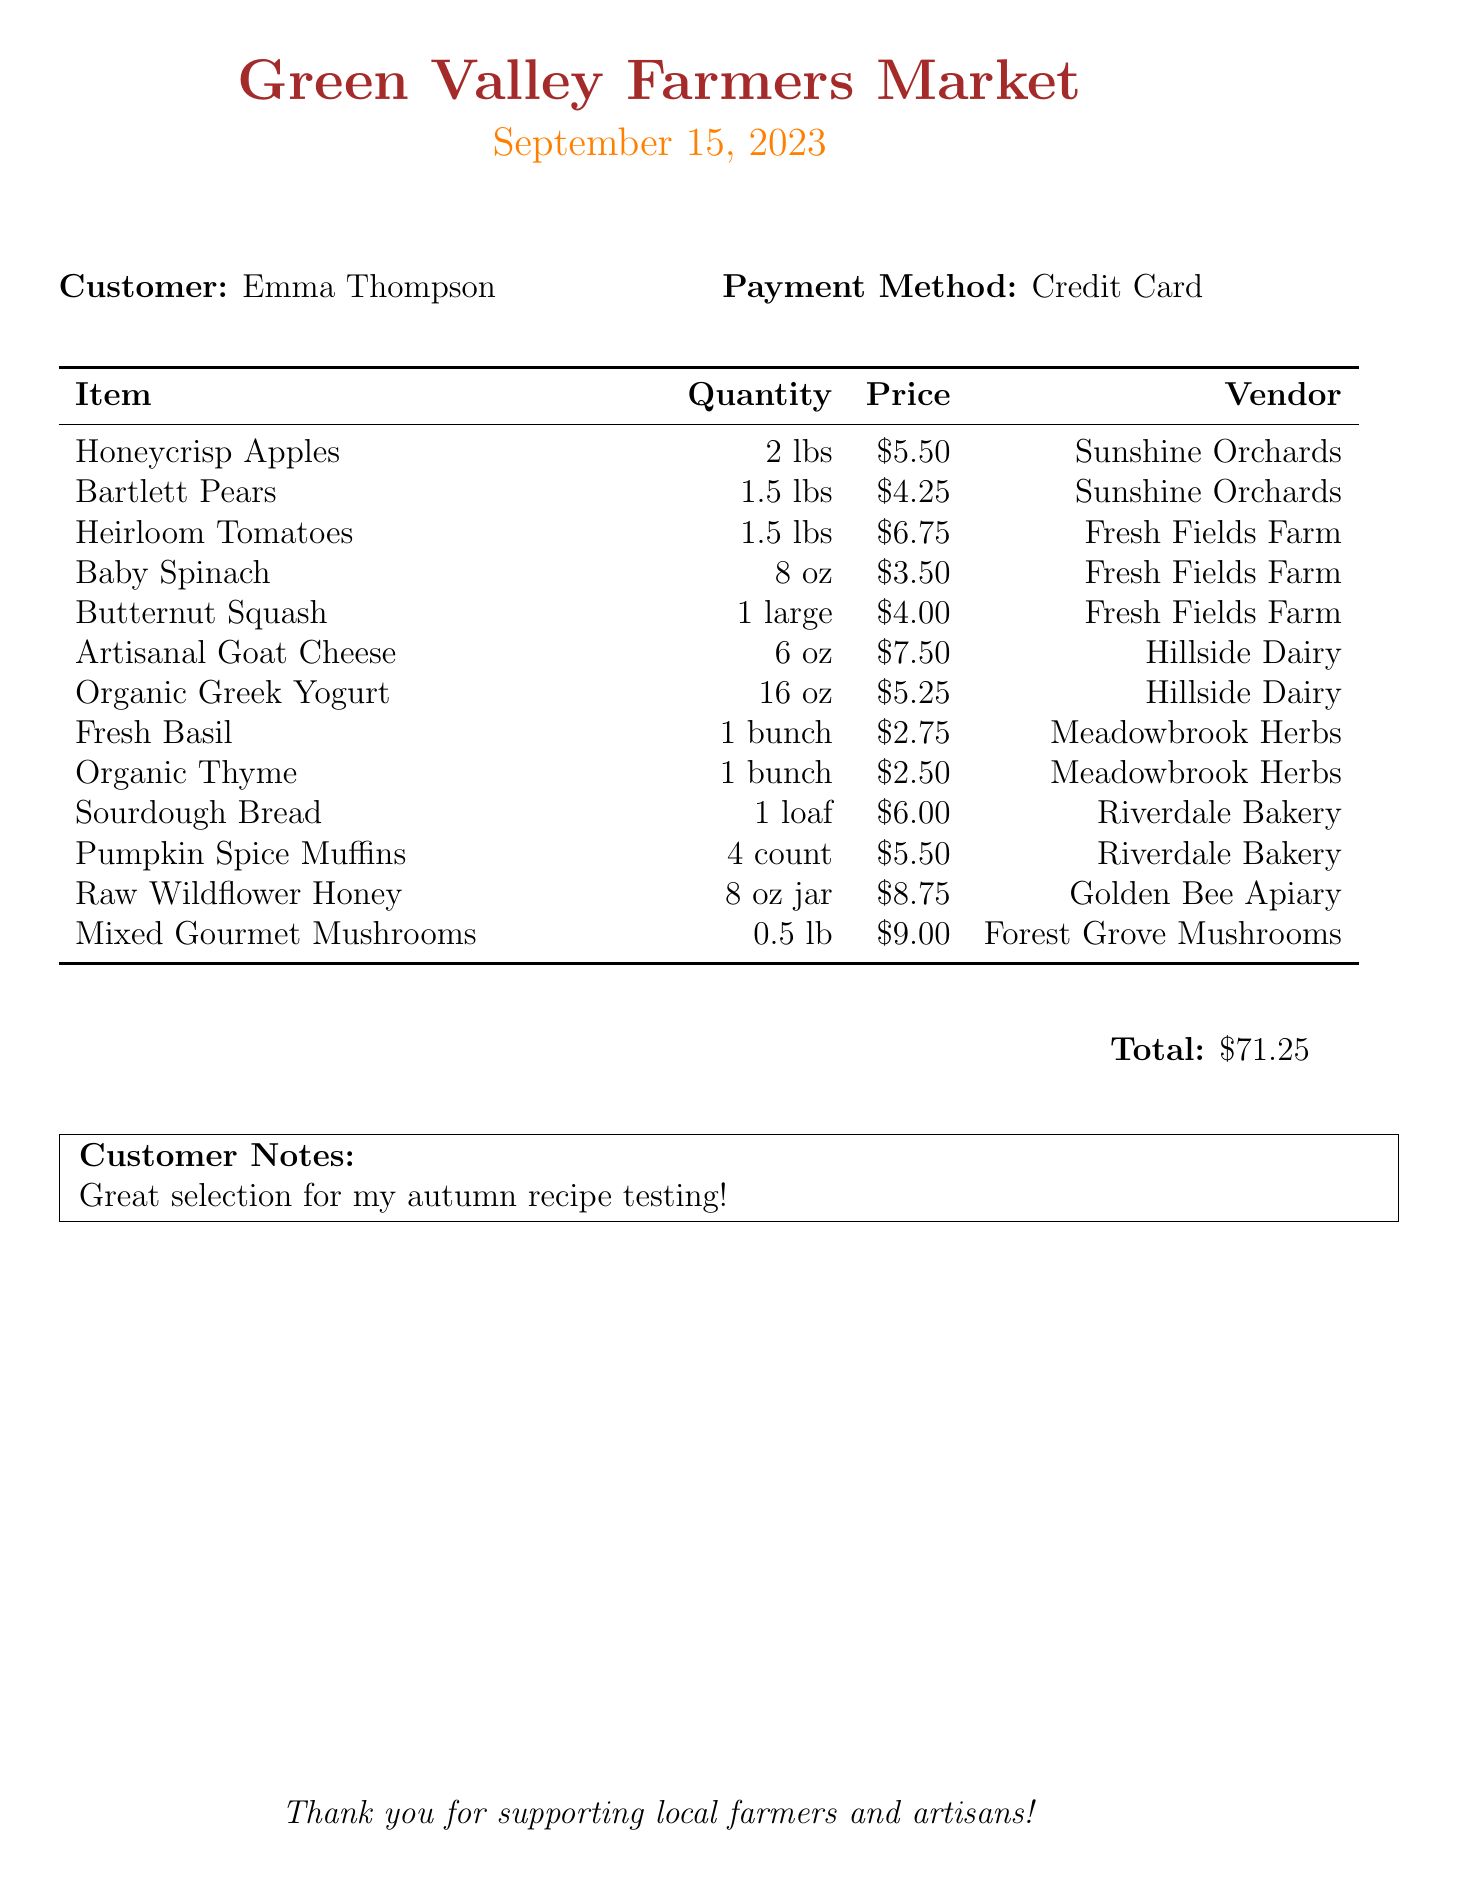What is the market name? The market name is mentioned at the top of the receipt.
Answer: Green Valley Farmers Market What is the date of purchase? The date of the receipt is provided under the market name.
Answer: September 15, 2023 Who is the customer? The customer’s name is displayed near the payment method.
Answer: Emma Thompson What is the total amount spent? The total amount is noted at the bottom of the receipt.
Answer: $71.25 How many pounds of Honeycrisp Apples were purchased? The quantity of Honeycrisp Apples is listed with their price.
Answer: 2 lbs What vendor sells Mixed Gourmet Mushrooms? The vendor's name is specified next to the item on the receipt.
Answer: Forest Grove Mushrooms Which item costs the most? This requires comparing all item prices listed.
Answer: Mixed Gourmet Mushrooms What payment method was used? The payment method is stated clearly on the receipt.
Answer: Credit Card Which vendor provides Raw Wildflower Honey? The vendor providing this product is mentioned along with the item.
Answer: Golden Bee Apiary 